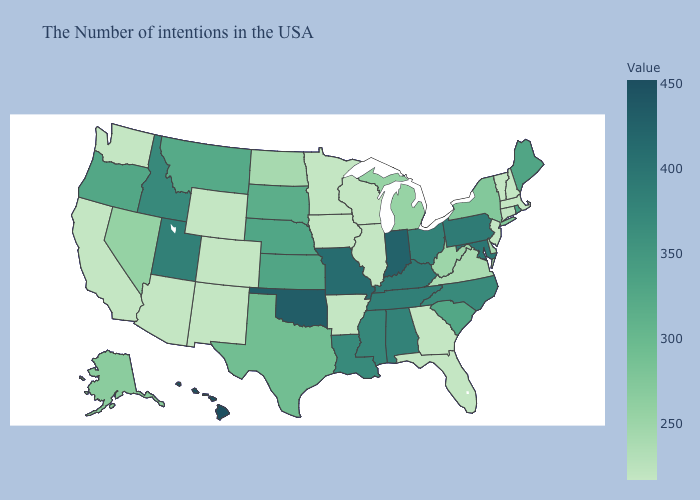Which states have the lowest value in the South?
Short answer required. Florida, Georgia, Arkansas. Does Pennsylvania have the highest value in the Northeast?
Short answer required. Yes. Which states have the lowest value in the MidWest?
Short answer required. Wisconsin, Illinois, Minnesota, Iowa. Among the states that border Iowa , which have the highest value?
Concise answer only. Missouri. 